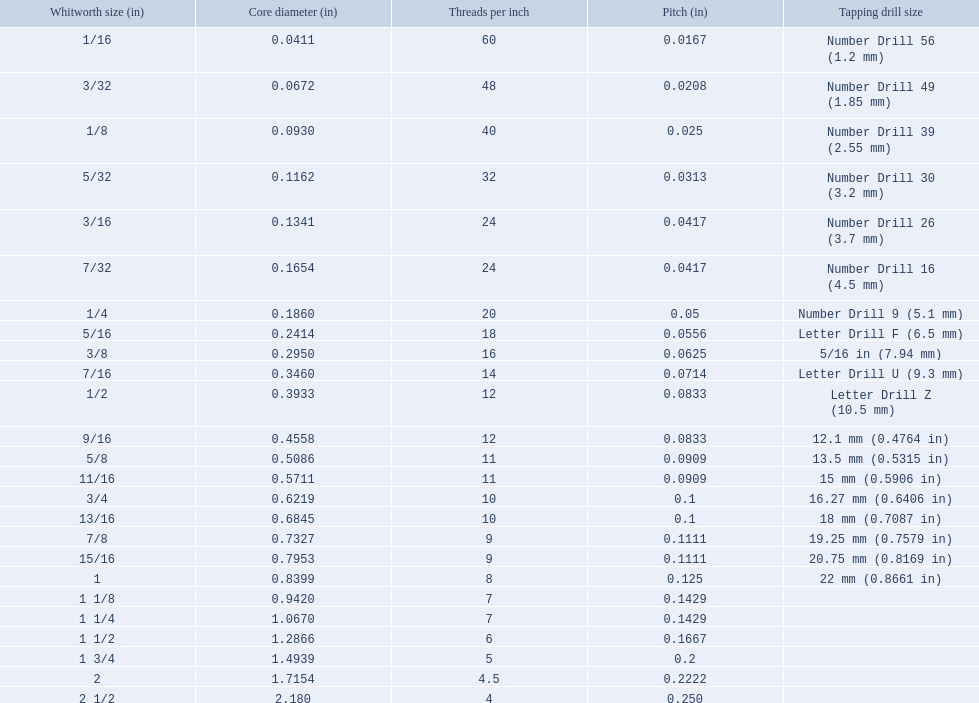What are all the whitworth values in the british standard whitworth? 1/16, 3/32, 1/8, 5/32, 3/16, 7/32, 1/4, 5/16, 3/8, 7/16, 1/2, 9/16, 5/8, 11/16, 3/4, 13/16, 7/8, 15/16, 1, 1 1/8, 1 1/4, 1 1/2, 1 3/4, 2, 2 1/2. Which of these values makes use of a tapping drill size of 26? 3/16. 